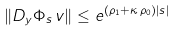<formula> <loc_0><loc_0><loc_500><loc_500>\| D _ { y } \Phi _ { s } \, v \| \leq e ^ { ( \rho _ { 1 } + \kappa \, \rho _ { 0 } ) | s | }</formula> 